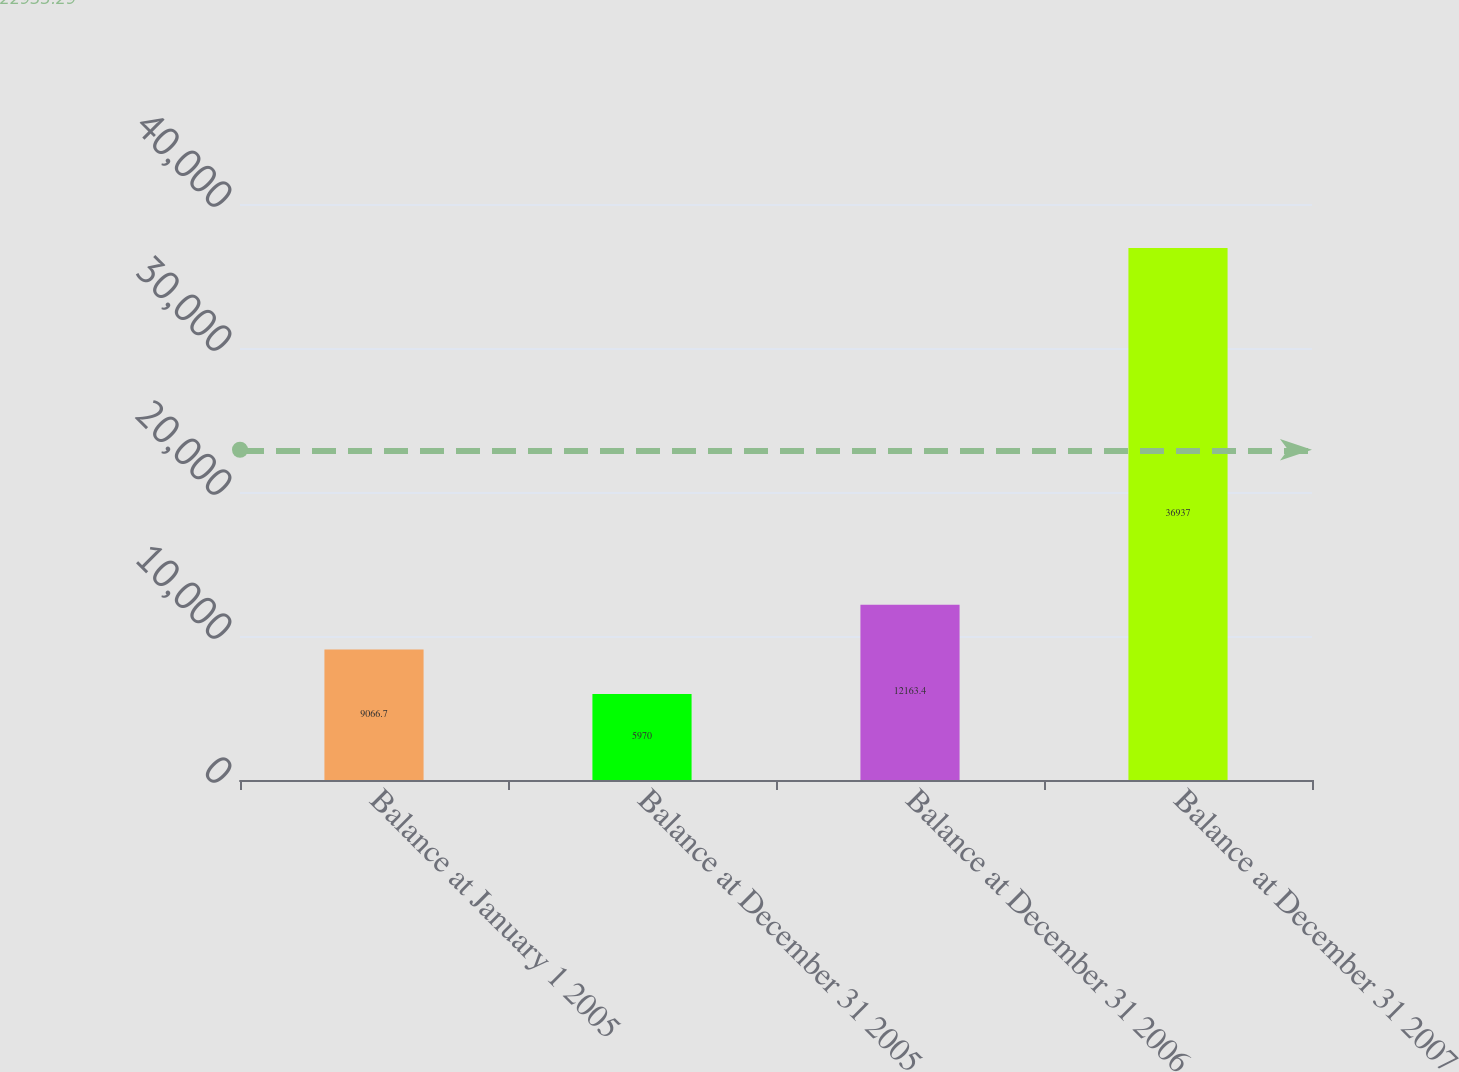<chart> <loc_0><loc_0><loc_500><loc_500><bar_chart><fcel>Balance at January 1 2005<fcel>Balance at December 31 2005<fcel>Balance at December 31 2006<fcel>Balance at December 31 2007<nl><fcel>9066.7<fcel>5970<fcel>12163.4<fcel>36937<nl></chart> 